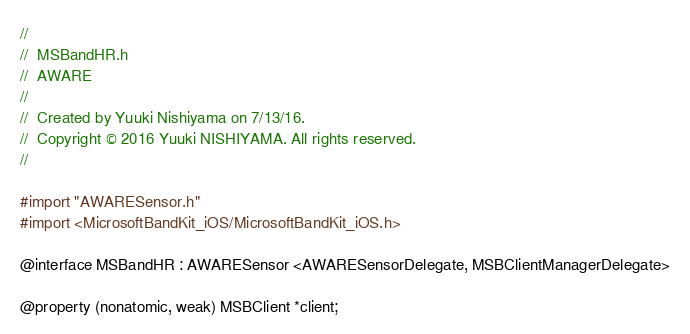<code> <loc_0><loc_0><loc_500><loc_500><_C_>//
//  MSBandHR.h
//  AWARE
//
//  Created by Yuuki Nishiyama on 7/13/16.
//  Copyright © 2016 Yuuki NISHIYAMA. All rights reserved.
//

#import "AWARESensor.h"
#import <MicrosoftBandKit_iOS/MicrosoftBandKit_iOS.h>

@interface MSBandHR : AWARESensor <AWARESensorDelegate, MSBClientManagerDelegate>

@property (nonatomic, weak) MSBClient *client;
</code> 